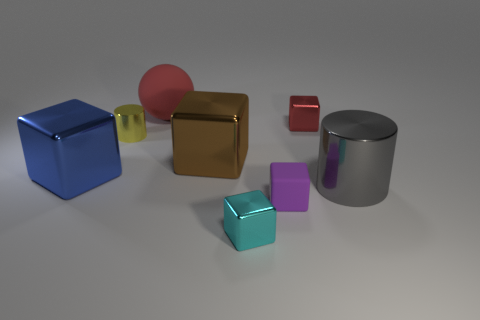Do the cyan metallic block and the brown thing have the same size?
Provide a short and direct response. No. How many things are either gray metallic objects or purple rubber things?
Your answer should be very brief. 2. What is the size of the shiny thing that is in front of the brown shiny block and on the left side of the large red rubber object?
Your answer should be compact. Large. Is the number of metal blocks left of the big rubber object less than the number of small yellow things?
Ensure brevity in your answer.  No. There is a thing that is the same material as the large sphere; what shape is it?
Your answer should be compact. Cube. Does the rubber object that is in front of the yellow object have the same shape as the tiny metallic object that is in front of the large blue metal object?
Offer a terse response. Yes. Are there fewer small metallic blocks behind the matte ball than big red rubber things that are to the right of the red cube?
Make the answer very short. No. There is a metal object that is the same color as the large matte thing; what is its shape?
Offer a terse response. Cube. What number of purple cubes are the same size as the brown thing?
Offer a terse response. 0. Is the material of the cube in front of the rubber cube the same as the small purple cube?
Offer a very short reply. No. 